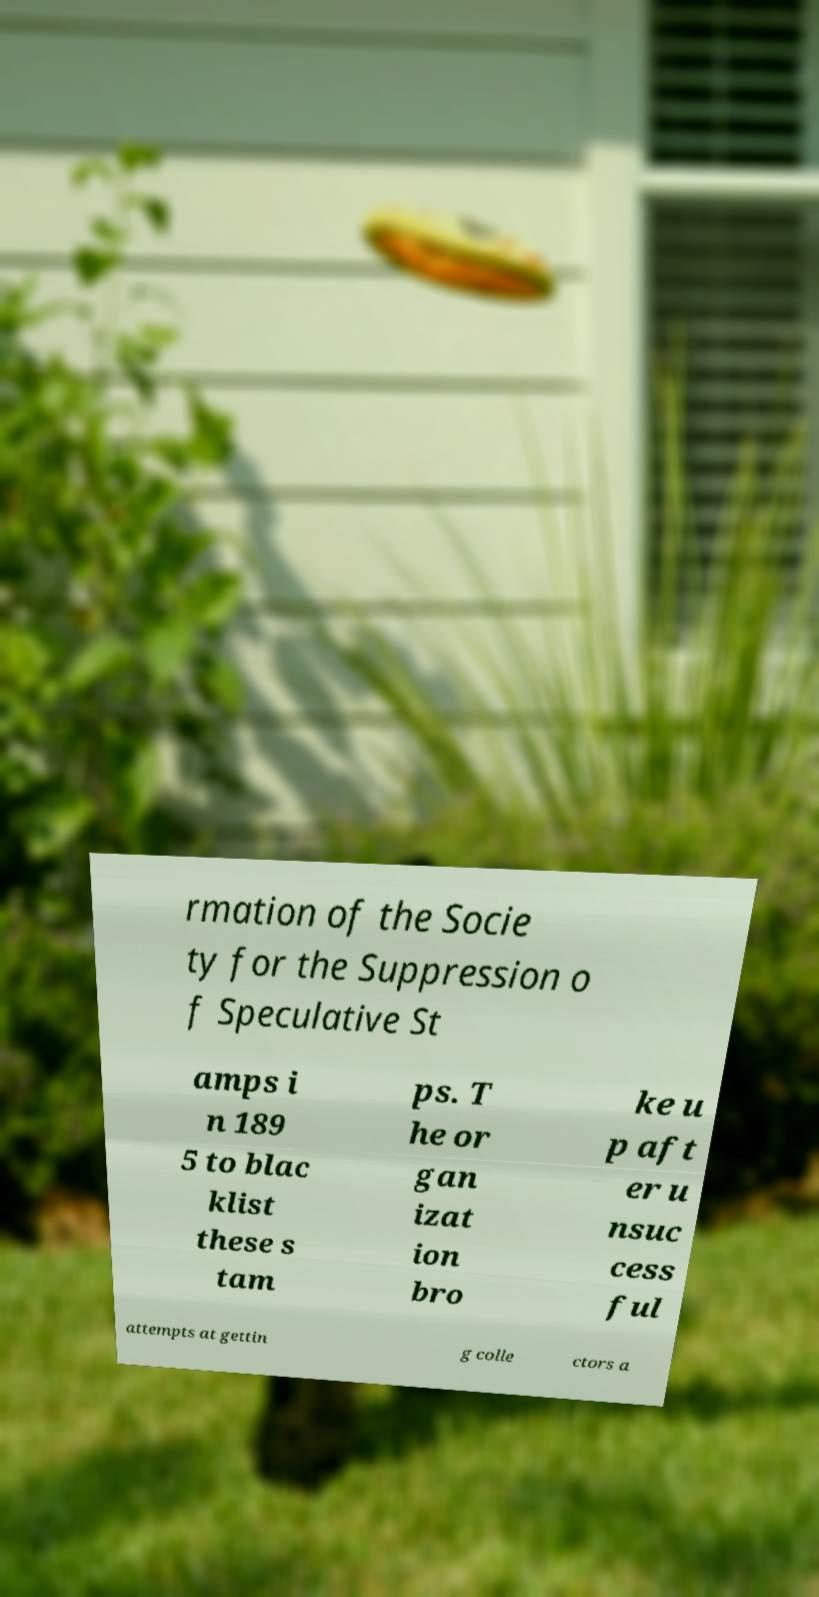Could you assist in decoding the text presented in this image and type it out clearly? rmation of the Socie ty for the Suppression o f Speculative St amps i n 189 5 to blac klist these s tam ps. T he or gan izat ion bro ke u p aft er u nsuc cess ful attempts at gettin g colle ctors a 